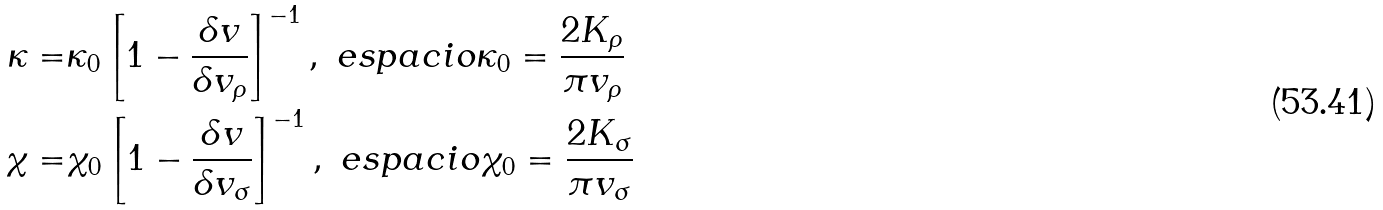Convert formula to latex. <formula><loc_0><loc_0><loc_500><loc_500>\kappa = & \kappa _ { 0 } \left [ 1 - \frac { \delta v } { \delta v _ { \rho } } \right ] ^ { - 1 } , \ e s p a c i o \kappa _ { 0 } = \frac { 2 K _ { \rho } } { \pi v _ { \rho } } \\ \chi = & \chi _ { 0 } \left [ 1 - \frac { \delta v } { \delta v _ { \sigma } } \right ] ^ { - 1 } , \ e s p a c i o \chi _ { 0 } = \frac { 2 K _ { \sigma } } { \pi v _ { \sigma } }</formula> 